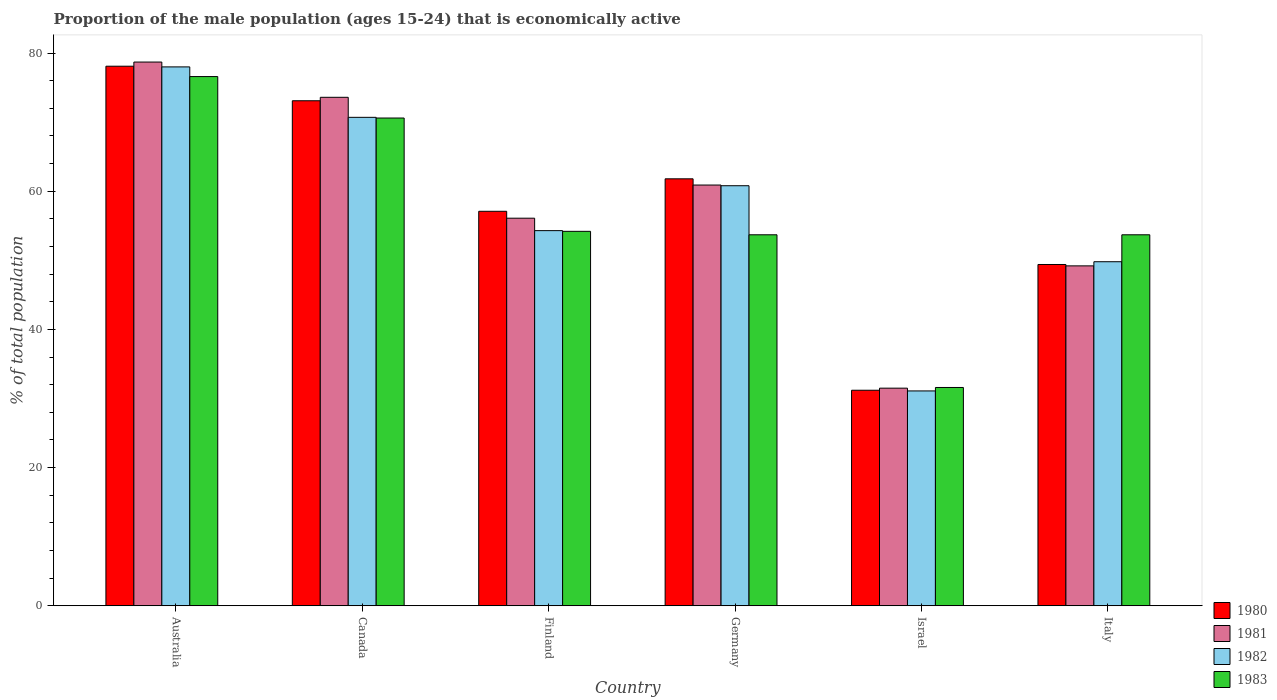What is the label of the 2nd group of bars from the left?
Provide a short and direct response. Canada. Across all countries, what is the minimum proportion of the male population that is economically active in 1980?
Make the answer very short. 31.2. In which country was the proportion of the male population that is economically active in 1982 minimum?
Provide a succinct answer. Israel. What is the total proportion of the male population that is economically active in 1982 in the graph?
Your response must be concise. 344.7. What is the difference between the proportion of the male population that is economically active in 1982 in Australia and that in Canada?
Ensure brevity in your answer.  7.3. What is the difference between the proportion of the male population that is economically active in 1982 in Italy and the proportion of the male population that is economically active in 1983 in Finland?
Offer a terse response. -4.4. What is the average proportion of the male population that is economically active in 1983 per country?
Offer a very short reply. 56.73. What is the difference between the proportion of the male population that is economically active of/in 1983 and proportion of the male population that is economically active of/in 1981 in Israel?
Your response must be concise. 0.1. What is the ratio of the proportion of the male population that is economically active in 1981 in Australia to that in Israel?
Provide a succinct answer. 2.5. Is the difference between the proportion of the male population that is economically active in 1983 in Finland and Italy greater than the difference between the proportion of the male population that is economically active in 1981 in Finland and Italy?
Provide a succinct answer. No. What is the difference between the highest and the second highest proportion of the male population that is economically active in 1983?
Your answer should be very brief. -22.4. What is the difference between the highest and the lowest proportion of the male population that is economically active in 1980?
Give a very brief answer. 46.9. In how many countries, is the proportion of the male population that is economically active in 1980 greater than the average proportion of the male population that is economically active in 1980 taken over all countries?
Provide a short and direct response. 3. Is it the case that in every country, the sum of the proportion of the male population that is economically active in 1982 and proportion of the male population that is economically active in 1983 is greater than the sum of proportion of the male population that is economically active in 1981 and proportion of the male population that is economically active in 1980?
Give a very brief answer. No. How many countries are there in the graph?
Your response must be concise. 6. What is the difference between two consecutive major ticks on the Y-axis?
Offer a terse response. 20. Are the values on the major ticks of Y-axis written in scientific E-notation?
Offer a terse response. No. Does the graph contain any zero values?
Ensure brevity in your answer.  No. Does the graph contain grids?
Your answer should be compact. No. How many legend labels are there?
Give a very brief answer. 4. What is the title of the graph?
Provide a short and direct response. Proportion of the male population (ages 15-24) that is economically active. What is the label or title of the Y-axis?
Offer a terse response. % of total population. What is the % of total population of 1980 in Australia?
Offer a terse response. 78.1. What is the % of total population of 1981 in Australia?
Keep it short and to the point. 78.7. What is the % of total population in 1982 in Australia?
Your answer should be compact. 78. What is the % of total population in 1983 in Australia?
Your response must be concise. 76.6. What is the % of total population in 1980 in Canada?
Ensure brevity in your answer.  73.1. What is the % of total population in 1981 in Canada?
Your answer should be compact. 73.6. What is the % of total population in 1982 in Canada?
Ensure brevity in your answer.  70.7. What is the % of total population of 1983 in Canada?
Provide a short and direct response. 70.6. What is the % of total population in 1980 in Finland?
Your answer should be very brief. 57.1. What is the % of total population in 1981 in Finland?
Offer a very short reply. 56.1. What is the % of total population of 1982 in Finland?
Your answer should be compact. 54.3. What is the % of total population in 1983 in Finland?
Provide a succinct answer. 54.2. What is the % of total population in 1980 in Germany?
Ensure brevity in your answer.  61.8. What is the % of total population in 1981 in Germany?
Give a very brief answer. 60.9. What is the % of total population of 1982 in Germany?
Your answer should be very brief. 60.8. What is the % of total population in 1983 in Germany?
Your answer should be compact. 53.7. What is the % of total population of 1980 in Israel?
Provide a short and direct response. 31.2. What is the % of total population of 1981 in Israel?
Offer a very short reply. 31.5. What is the % of total population in 1982 in Israel?
Offer a terse response. 31.1. What is the % of total population of 1983 in Israel?
Offer a very short reply. 31.6. What is the % of total population of 1980 in Italy?
Provide a short and direct response. 49.4. What is the % of total population in 1981 in Italy?
Give a very brief answer. 49.2. What is the % of total population in 1982 in Italy?
Provide a succinct answer. 49.8. What is the % of total population of 1983 in Italy?
Ensure brevity in your answer.  53.7. Across all countries, what is the maximum % of total population in 1980?
Provide a succinct answer. 78.1. Across all countries, what is the maximum % of total population in 1981?
Keep it short and to the point. 78.7. Across all countries, what is the maximum % of total population of 1983?
Your answer should be compact. 76.6. Across all countries, what is the minimum % of total population of 1980?
Keep it short and to the point. 31.2. Across all countries, what is the minimum % of total population in 1981?
Your response must be concise. 31.5. Across all countries, what is the minimum % of total population of 1982?
Provide a short and direct response. 31.1. Across all countries, what is the minimum % of total population of 1983?
Your response must be concise. 31.6. What is the total % of total population in 1980 in the graph?
Give a very brief answer. 350.7. What is the total % of total population of 1981 in the graph?
Provide a short and direct response. 350. What is the total % of total population of 1982 in the graph?
Give a very brief answer. 344.7. What is the total % of total population of 1983 in the graph?
Keep it short and to the point. 340.4. What is the difference between the % of total population in 1980 in Australia and that in Canada?
Offer a terse response. 5. What is the difference between the % of total population in 1982 in Australia and that in Canada?
Offer a terse response. 7.3. What is the difference between the % of total population in 1983 in Australia and that in Canada?
Keep it short and to the point. 6. What is the difference between the % of total population of 1980 in Australia and that in Finland?
Keep it short and to the point. 21. What is the difference between the % of total population in 1981 in Australia and that in Finland?
Provide a short and direct response. 22.6. What is the difference between the % of total population in 1982 in Australia and that in Finland?
Your response must be concise. 23.7. What is the difference between the % of total population in 1983 in Australia and that in Finland?
Your answer should be very brief. 22.4. What is the difference between the % of total population of 1980 in Australia and that in Germany?
Your answer should be compact. 16.3. What is the difference between the % of total population of 1981 in Australia and that in Germany?
Ensure brevity in your answer.  17.8. What is the difference between the % of total population in 1983 in Australia and that in Germany?
Make the answer very short. 22.9. What is the difference between the % of total population of 1980 in Australia and that in Israel?
Your answer should be very brief. 46.9. What is the difference between the % of total population in 1981 in Australia and that in Israel?
Your answer should be compact. 47.2. What is the difference between the % of total population of 1982 in Australia and that in Israel?
Keep it short and to the point. 46.9. What is the difference between the % of total population in 1983 in Australia and that in Israel?
Keep it short and to the point. 45. What is the difference between the % of total population in 1980 in Australia and that in Italy?
Give a very brief answer. 28.7. What is the difference between the % of total population in 1981 in Australia and that in Italy?
Ensure brevity in your answer.  29.5. What is the difference between the % of total population in 1982 in Australia and that in Italy?
Your response must be concise. 28.2. What is the difference between the % of total population of 1983 in Australia and that in Italy?
Offer a very short reply. 22.9. What is the difference between the % of total population in 1980 in Canada and that in Finland?
Offer a terse response. 16. What is the difference between the % of total population of 1982 in Canada and that in Finland?
Your answer should be very brief. 16.4. What is the difference between the % of total population of 1980 in Canada and that in Germany?
Make the answer very short. 11.3. What is the difference between the % of total population in 1981 in Canada and that in Germany?
Keep it short and to the point. 12.7. What is the difference between the % of total population of 1982 in Canada and that in Germany?
Your response must be concise. 9.9. What is the difference between the % of total population in 1980 in Canada and that in Israel?
Give a very brief answer. 41.9. What is the difference between the % of total population in 1981 in Canada and that in Israel?
Your response must be concise. 42.1. What is the difference between the % of total population in 1982 in Canada and that in Israel?
Offer a terse response. 39.6. What is the difference between the % of total population of 1980 in Canada and that in Italy?
Give a very brief answer. 23.7. What is the difference between the % of total population in 1981 in Canada and that in Italy?
Your answer should be compact. 24.4. What is the difference between the % of total population in 1982 in Canada and that in Italy?
Give a very brief answer. 20.9. What is the difference between the % of total population of 1980 in Finland and that in Germany?
Make the answer very short. -4.7. What is the difference between the % of total population of 1981 in Finland and that in Germany?
Provide a short and direct response. -4.8. What is the difference between the % of total population of 1980 in Finland and that in Israel?
Your answer should be compact. 25.9. What is the difference between the % of total population in 1981 in Finland and that in Israel?
Provide a short and direct response. 24.6. What is the difference between the % of total population of 1982 in Finland and that in Israel?
Provide a succinct answer. 23.2. What is the difference between the % of total population in 1983 in Finland and that in Israel?
Provide a short and direct response. 22.6. What is the difference between the % of total population in 1981 in Finland and that in Italy?
Provide a short and direct response. 6.9. What is the difference between the % of total population of 1980 in Germany and that in Israel?
Your response must be concise. 30.6. What is the difference between the % of total population in 1981 in Germany and that in Israel?
Offer a terse response. 29.4. What is the difference between the % of total population of 1982 in Germany and that in Israel?
Offer a very short reply. 29.7. What is the difference between the % of total population in 1983 in Germany and that in Israel?
Offer a terse response. 22.1. What is the difference between the % of total population of 1980 in Germany and that in Italy?
Offer a terse response. 12.4. What is the difference between the % of total population of 1982 in Germany and that in Italy?
Ensure brevity in your answer.  11. What is the difference between the % of total population in 1980 in Israel and that in Italy?
Ensure brevity in your answer.  -18.2. What is the difference between the % of total population in 1981 in Israel and that in Italy?
Your answer should be very brief. -17.7. What is the difference between the % of total population in 1982 in Israel and that in Italy?
Provide a succinct answer. -18.7. What is the difference between the % of total population of 1983 in Israel and that in Italy?
Offer a very short reply. -22.1. What is the difference between the % of total population in 1981 in Australia and the % of total population in 1983 in Canada?
Your response must be concise. 8.1. What is the difference between the % of total population in 1982 in Australia and the % of total population in 1983 in Canada?
Provide a succinct answer. 7.4. What is the difference between the % of total population in 1980 in Australia and the % of total population in 1981 in Finland?
Keep it short and to the point. 22. What is the difference between the % of total population in 1980 in Australia and the % of total population in 1982 in Finland?
Offer a terse response. 23.8. What is the difference between the % of total population of 1980 in Australia and the % of total population of 1983 in Finland?
Your response must be concise. 23.9. What is the difference between the % of total population in 1981 in Australia and the % of total population in 1982 in Finland?
Offer a very short reply. 24.4. What is the difference between the % of total population of 1982 in Australia and the % of total population of 1983 in Finland?
Give a very brief answer. 23.8. What is the difference between the % of total population of 1980 in Australia and the % of total population of 1981 in Germany?
Offer a terse response. 17.2. What is the difference between the % of total population of 1980 in Australia and the % of total population of 1982 in Germany?
Offer a very short reply. 17.3. What is the difference between the % of total population in 1980 in Australia and the % of total population in 1983 in Germany?
Your answer should be very brief. 24.4. What is the difference between the % of total population of 1981 in Australia and the % of total population of 1983 in Germany?
Provide a succinct answer. 25. What is the difference between the % of total population in 1982 in Australia and the % of total population in 1983 in Germany?
Offer a terse response. 24.3. What is the difference between the % of total population of 1980 in Australia and the % of total population of 1981 in Israel?
Keep it short and to the point. 46.6. What is the difference between the % of total population of 1980 in Australia and the % of total population of 1982 in Israel?
Your response must be concise. 47. What is the difference between the % of total population in 1980 in Australia and the % of total population in 1983 in Israel?
Your answer should be very brief. 46.5. What is the difference between the % of total population in 1981 in Australia and the % of total population in 1982 in Israel?
Keep it short and to the point. 47.6. What is the difference between the % of total population in 1981 in Australia and the % of total population in 1983 in Israel?
Offer a very short reply. 47.1. What is the difference between the % of total population of 1982 in Australia and the % of total population of 1983 in Israel?
Your response must be concise. 46.4. What is the difference between the % of total population of 1980 in Australia and the % of total population of 1981 in Italy?
Offer a terse response. 28.9. What is the difference between the % of total population in 1980 in Australia and the % of total population in 1982 in Italy?
Offer a very short reply. 28.3. What is the difference between the % of total population in 1980 in Australia and the % of total population in 1983 in Italy?
Give a very brief answer. 24.4. What is the difference between the % of total population of 1981 in Australia and the % of total population of 1982 in Italy?
Provide a succinct answer. 28.9. What is the difference between the % of total population of 1982 in Australia and the % of total population of 1983 in Italy?
Your answer should be compact. 24.3. What is the difference between the % of total population in 1980 in Canada and the % of total population in 1981 in Finland?
Make the answer very short. 17. What is the difference between the % of total population in 1980 in Canada and the % of total population in 1982 in Finland?
Offer a terse response. 18.8. What is the difference between the % of total population in 1981 in Canada and the % of total population in 1982 in Finland?
Make the answer very short. 19.3. What is the difference between the % of total population of 1980 in Canada and the % of total population of 1981 in Germany?
Ensure brevity in your answer.  12.2. What is the difference between the % of total population in 1980 in Canada and the % of total population in 1983 in Germany?
Offer a very short reply. 19.4. What is the difference between the % of total population of 1981 in Canada and the % of total population of 1982 in Germany?
Your answer should be compact. 12.8. What is the difference between the % of total population in 1981 in Canada and the % of total population in 1983 in Germany?
Make the answer very short. 19.9. What is the difference between the % of total population of 1980 in Canada and the % of total population of 1981 in Israel?
Make the answer very short. 41.6. What is the difference between the % of total population of 1980 in Canada and the % of total population of 1983 in Israel?
Keep it short and to the point. 41.5. What is the difference between the % of total population in 1981 in Canada and the % of total population in 1982 in Israel?
Your answer should be very brief. 42.5. What is the difference between the % of total population of 1981 in Canada and the % of total population of 1983 in Israel?
Your response must be concise. 42. What is the difference between the % of total population of 1982 in Canada and the % of total population of 1983 in Israel?
Provide a short and direct response. 39.1. What is the difference between the % of total population of 1980 in Canada and the % of total population of 1981 in Italy?
Keep it short and to the point. 23.9. What is the difference between the % of total population in 1980 in Canada and the % of total population in 1982 in Italy?
Ensure brevity in your answer.  23.3. What is the difference between the % of total population of 1980 in Canada and the % of total population of 1983 in Italy?
Make the answer very short. 19.4. What is the difference between the % of total population in 1981 in Canada and the % of total population in 1982 in Italy?
Provide a short and direct response. 23.8. What is the difference between the % of total population of 1982 in Canada and the % of total population of 1983 in Italy?
Keep it short and to the point. 17. What is the difference between the % of total population of 1980 in Finland and the % of total population of 1981 in Germany?
Your answer should be compact. -3.8. What is the difference between the % of total population of 1980 in Finland and the % of total population of 1982 in Germany?
Provide a succinct answer. -3.7. What is the difference between the % of total population of 1980 in Finland and the % of total population of 1983 in Germany?
Keep it short and to the point. 3.4. What is the difference between the % of total population of 1981 in Finland and the % of total population of 1983 in Germany?
Ensure brevity in your answer.  2.4. What is the difference between the % of total population of 1980 in Finland and the % of total population of 1981 in Israel?
Provide a succinct answer. 25.6. What is the difference between the % of total population of 1980 in Finland and the % of total population of 1983 in Israel?
Offer a very short reply. 25.5. What is the difference between the % of total population in 1981 in Finland and the % of total population in 1982 in Israel?
Offer a very short reply. 25. What is the difference between the % of total population in 1982 in Finland and the % of total population in 1983 in Israel?
Offer a terse response. 22.7. What is the difference between the % of total population of 1980 in Finland and the % of total population of 1981 in Italy?
Your response must be concise. 7.9. What is the difference between the % of total population of 1981 in Finland and the % of total population of 1983 in Italy?
Offer a very short reply. 2.4. What is the difference between the % of total population in 1980 in Germany and the % of total population in 1981 in Israel?
Offer a very short reply. 30.3. What is the difference between the % of total population in 1980 in Germany and the % of total population in 1982 in Israel?
Give a very brief answer. 30.7. What is the difference between the % of total population in 1980 in Germany and the % of total population in 1983 in Israel?
Give a very brief answer. 30.2. What is the difference between the % of total population of 1981 in Germany and the % of total population of 1982 in Israel?
Give a very brief answer. 29.8. What is the difference between the % of total population of 1981 in Germany and the % of total population of 1983 in Israel?
Keep it short and to the point. 29.3. What is the difference between the % of total population of 1982 in Germany and the % of total population of 1983 in Israel?
Give a very brief answer. 29.2. What is the difference between the % of total population of 1980 in Germany and the % of total population of 1982 in Italy?
Provide a short and direct response. 12. What is the difference between the % of total population of 1981 in Germany and the % of total population of 1982 in Italy?
Make the answer very short. 11.1. What is the difference between the % of total population of 1981 in Germany and the % of total population of 1983 in Italy?
Your response must be concise. 7.2. What is the difference between the % of total population in 1982 in Germany and the % of total population in 1983 in Italy?
Your response must be concise. 7.1. What is the difference between the % of total population in 1980 in Israel and the % of total population in 1982 in Italy?
Provide a succinct answer. -18.6. What is the difference between the % of total population in 1980 in Israel and the % of total population in 1983 in Italy?
Your answer should be very brief. -22.5. What is the difference between the % of total population in 1981 in Israel and the % of total population in 1982 in Italy?
Make the answer very short. -18.3. What is the difference between the % of total population of 1981 in Israel and the % of total population of 1983 in Italy?
Your answer should be very brief. -22.2. What is the difference between the % of total population in 1982 in Israel and the % of total population in 1983 in Italy?
Keep it short and to the point. -22.6. What is the average % of total population in 1980 per country?
Provide a short and direct response. 58.45. What is the average % of total population of 1981 per country?
Give a very brief answer. 58.33. What is the average % of total population in 1982 per country?
Give a very brief answer. 57.45. What is the average % of total population in 1983 per country?
Give a very brief answer. 56.73. What is the difference between the % of total population in 1980 and % of total population in 1981 in Australia?
Provide a short and direct response. -0.6. What is the difference between the % of total population of 1980 and % of total population of 1982 in Australia?
Your answer should be very brief. 0.1. What is the difference between the % of total population of 1980 and % of total population of 1983 in Australia?
Provide a short and direct response. 1.5. What is the difference between the % of total population in 1980 and % of total population in 1983 in Canada?
Make the answer very short. 2.5. What is the difference between the % of total population of 1981 and % of total population of 1983 in Canada?
Offer a very short reply. 3. What is the difference between the % of total population of 1982 and % of total population of 1983 in Canada?
Offer a terse response. 0.1. What is the difference between the % of total population of 1980 and % of total population of 1981 in Finland?
Offer a terse response. 1. What is the difference between the % of total population in 1980 and % of total population in 1983 in Finland?
Provide a succinct answer. 2.9. What is the difference between the % of total population of 1981 and % of total population of 1982 in Finland?
Give a very brief answer. 1.8. What is the difference between the % of total population of 1981 and % of total population of 1983 in Finland?
Make the answer very short. 1.9. What is the difference between the % of total population in 1980 and % of total population in 1983 in Germany?
Your answer should be compact. 8.1. What is the difference between the % of total population in 1981 and % of total population in 1983 in Germany?
Keep it short and to the point. 7.2. What is the difference between the % of total population of 1980 and % of total population of 1981 in Israel?
Offer a very short reply. -0.3. What is the difference between the % of total population of 1980 and % of total population of 1982 in Israel?
Ensure brevity in your answer.  0.1. What is the difference between the % of total population in 1981 and % of total population in 1983 in Israel?
Provide a succinct answer. -0.1. What is the difference between the % of total population in 1980 and % of total population in 1981 in Italy?
Your answer should be compact. 0.2. What is the difference between the % of total population of 1981 and % of total population of 1982 in Italy?
Ensure brevity in your answer.  -0.6. What is the difference between the % of total population of 1981 and % of total population of 1983 in Italy?
Your response must be concise. -4.5. What is the ratio of the % of total population in 1980 in Australia to that in Canada?
Your answer should be very brief. 1.07. What is the ratio of the % of total population in 1981 in Australia to that in Canada?
Provide a succinct answer. 1.07. What is the ratio of the % of total population in 1982 in Australia to that in Canada?
Keep it short and to the point. 1.1. What is the ratio of the % of total population of 1983 in Australia to that in Canada?
Your answer should be compact. 1.08. What is the ratio of the % of total population in 1980 in Australia to that in Finland?
Offer a very short reply. 1.37. What is the ratio of the % of total population of 1981 in Australia to that in Finland?
Your answer should be very brief. 1.4. What is the ratio of the % of total population in 1982 in Australia to that in Finland?
Keep it short and to the point. 1.44. What is the ratio of the % of total population in 1983 in Australia to that in Finland?
Your response must be concise. 1.41. What is the ratio of the % of total population of 1980 in Australia to that in Germany?
Make the answer very short. 1.26. What is the ratio of the % of total population in 1981 in Australia to that in Germany?
Offer a terse response. 1.29. What is the ratio of the % of total population in 1982 in Australia to that in Germany?
Offer a terse response. 1.28. What is the ratio of the % of total population of 1983 in Australia to that in Germany?
Offer a very short reply. 1.43. What is the ratio of the % of total population in 1980 in Australia to that in Israel?
Give a very brief answer. 2.5. What is the ratio of the % of total population in 1981 in Australia to that in Israel?
Ensure brevity in your answer.  2.5. What is the ratio of the % of total population of 1982 in Australia to that in Israel?
Offer a very short reply. 2.51. What is the ratio of the % of total population of 1983 in Australia to that in Israel?
Keep it short and to the point. 2.42. What is the ratio of the % of total population in 1980 in Australia to that in Italy?
Provide a short and direct response. 1.58. What is the ratio of the % of total population of 1981 in Australia to that in Italy?
Give a very brief answer. 1.6. What is the ratio of the % of total population in 1982 in Australia to that in Italy?
Your answer should be very brief. 1.57. What is the ratio of the % of total population of 1983 in Australia to that in Italy?
Your response must be concise. 1.43. What is the ratio of the % of total population in 1980 in Canada to that in Finland?
Offer a terse response. 1.28. What is the ratio of the % of total population in 1981 in Canada to that in Finland?
Keep it short and to the point. 1.31. What is the ratio of the % of total population in 1982 in Canada to that in Finland?
Your answer should be very brief. 1.3. What is the ratio of the % of total population in 1983 in Canada to that in Finland?
Keep it short and to the point. 1.3. What is the ratio of the % of total population in 1980 in Canada to that in Germany?
Your answer should be compact. 1.18. What is the ratio of the % of total population in 1981 in Canada to that in Germany?
Provide a succinct answer. 1.21. What is the ratio of the % of total population of 1982 in Canada to that in Germany?
Offer a very short reply. 1.16. What is the ratio of the % of total population of 1983 in Canada to that in Germany?
Your response must be concise. 1.31. What is the ratio of the % of total population in 1980 in Canada to that in Israel?
Your answer should be very brief. 2.34. What is the ratio of the % of total population in 1981 in Canada to that in Israel?
Your answer should be compact. 2.34. What is the ratio of the % of total population of 1982 in Canada to that in Israel?
Provide a short and direct response. 2.27. What is the ratio of the % of total population in 1983 in Canada to that in Israel?
Keep it short and to the point. 2.23. What is the ratio of the % of total population of 1980 in Canada to that in Italy?
Ensure brevity in your answer.  1.48. What is the ratio of the % of total population in 1981 in Canada to that in Italy?
Offer a very short reply. 1.5. What is the ratio of the % of total population of 1982 in Canada to that in Italy?
Offer a very short reply. 1.42. What is the ratio of the % of total population of 1983 in Canada to that in Italy?
Your response must be concise. 1.31. What is the ratio of the % of total population of 1980 in Finland to that in Germany?
Provide a short and direct response. 0.92. What is the ratio of the % of total population of 1981 in Finland to that in Germany?
Your response must be concise. 0.92. What is the ratio of the % of total population in 1982 in Finland to that in Germany?
Keep it short and to the point. 0.89. What is the ratio of the % of total population of 1983 in Finland to that in Germany?
Your answer should be compact. 1.01. What is the ratio of the % of total population of 1980 in Finland to that in Israel?
Your response must be concise. 1.83. What is the ratio of the % of total population in 1981 in Finland to that in Israel?
Provide a short and direct response. 1.78. What is the ratio of the % of total population in 1982 in Finland to that in Israel?
Make the answer very short. 1.75. What is the ratio of the % of total population of 1983 in Finland to that in Israel?
Ensure brevity in your answer.  1.72. What is the ratio of the % of total population in 1980 in Finland to that in Italy?
Offer a terse response. 1.16. What is the ratio of the % of total population in 1981 in Finland to that in Italy?
Give a very brief answer. 1.14. What is the ratio of the % of total population of 1982 in Finland to that in Italy?
Provide a short and direct response. 1.09. What is the ratio of the % of total population of 1983 in Finland to that in Italy?
Offer a terse response. 1.01. What is the ratio of the % of total population in 1980 in Germany to that in Israel?
Your answer should be compact. 1.98. What is the ratio of the % of total population in 1981 in Germany to that in Israel?
Make the answer very short. 1.93. What is the ratio of the % of total population in 1982 in Germany to that in Israel?
Your response must be concise. 1.96. What is the ratio of the % of total population in 1983 in Germany to that in Israel?
Provide a short and direct response. 1.7. What is the ratio of the % of total population of 1980 in Germany to that in Italy?
Offer a very short reply. 1.25. What is the ratio of the % of total population in 1981 in Germany to that in Italy?
Make the answer very short. 1.24. What is the ratio of the % of total population of 1982 in Germany to that in Italy?
Give a very brief answer. 1.22. What is the ratio of the % of total population in 1983 in Germany to that in Italy?
Your answer should be compact. 1. What is the ratio of the % of total population of 1980 in Israel to that in Italy?
Provide a short and direct response. 0.63. What is the ratio of the % of total population in 1981 in Israel to that in Italy?
Your answer should be very brief. 0.64. What is the ratio of the % of total population in 1982 in Israel to that in Italy?
Make the answer very short. 0.62. What is the ratio of the % of total population in 1983 in Israel to that in Italy?
Provide a short and direct response. 0.59. What is the difference between the highest and the second highest % of total population of 1980?
Your answer should be compact. 5. What is the difference between the highest and the second highest % of total population of 1982?
Offer a very short reply. 7.3. What is the difference between the highest and the second highest % of total population in 1983?
Make the answer very short. 6. What is the difference between the highest and the lowest % of total population in 1980?
Give a very brief answer. 46.9. What is the difference between the highest and the lowest % of total population in 1981?
Provide a succinct answer. 47.2. What is the difference between the highest and the lowest % of total population in 1982?
Offer a terse response. 46.9. What is the difference between the highest and the lowest % of total population of 1983?
Provide a succinct answer. 45. 